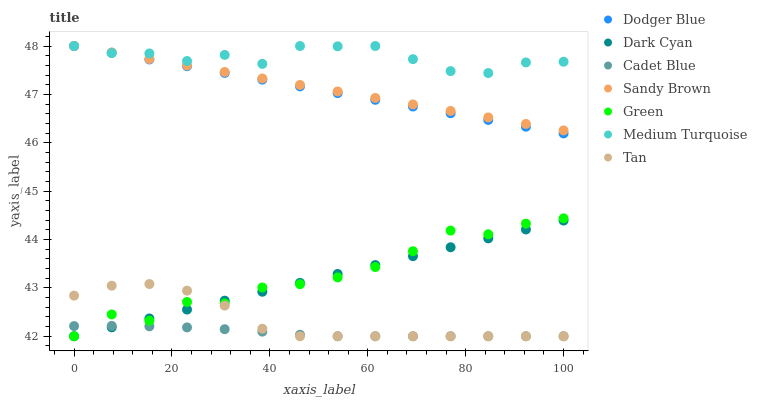Does Cadet Blue have the minimum area under the curve?
Answer yes or no. Yes. Does Medium Turquoise have the maximum area under the curve?
Answer yes or no. Yes. Does Dodger Blue have the minimum area under the curve?
Answer yes or no. No. Does Dodger Blue have the maximum area under the curve?
Answer yes or no. No. Is Dodger Blue the smoothest?
Answer yes or no. Yes. Is Green the roughest?
Answer yes or no. Yes. Is Medium Turquoise the smoothest?
Answer yes or no. No. Is Medium Turquoise the roughest?
Answer yes or no. No. Does Cadet Blue have the lowest value?
Answer yes or no. Yes. Does Dodger Blue have the lowest value?
Answer yes or no. No. Does Sandy Brown have the highest value?
Answer yes or no. Yes. Does Dark Cyan have the highest value?
Answer yes or no. No. Is Green less than Dodger Blue?
Answer yes or no. Yes. Is Sandy Brown greater than Dark Cyan?
Answer yes or no. Yes. Does Green intersect Dark Cyan?
Answer yes or no. Yes. Is Green less than Dark Cyan?
Answer yes or no. No. Is Green greater than Dark Cyan?
Answer yes or no. No. Does Green intersect Dodger Blue?
Answer yes or no. No. 